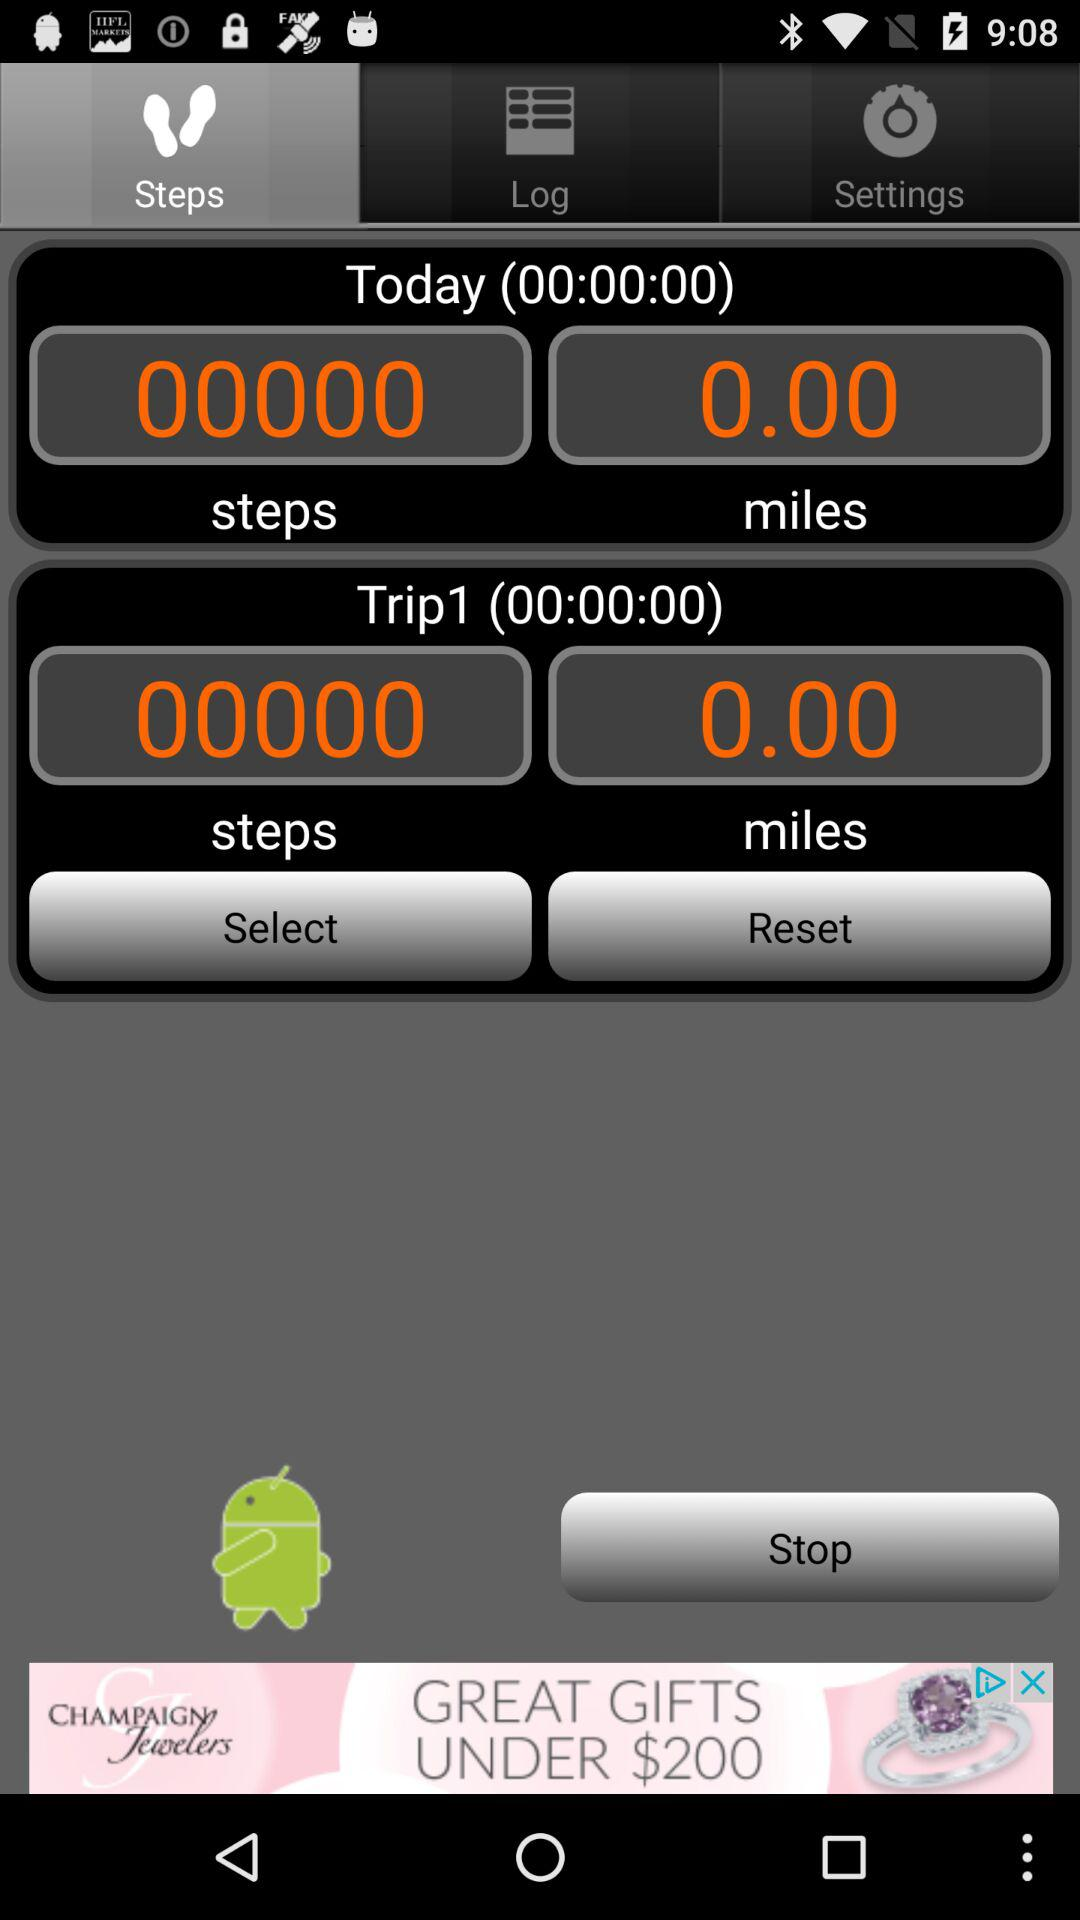What are today's steps? Today's steps are 00000. 